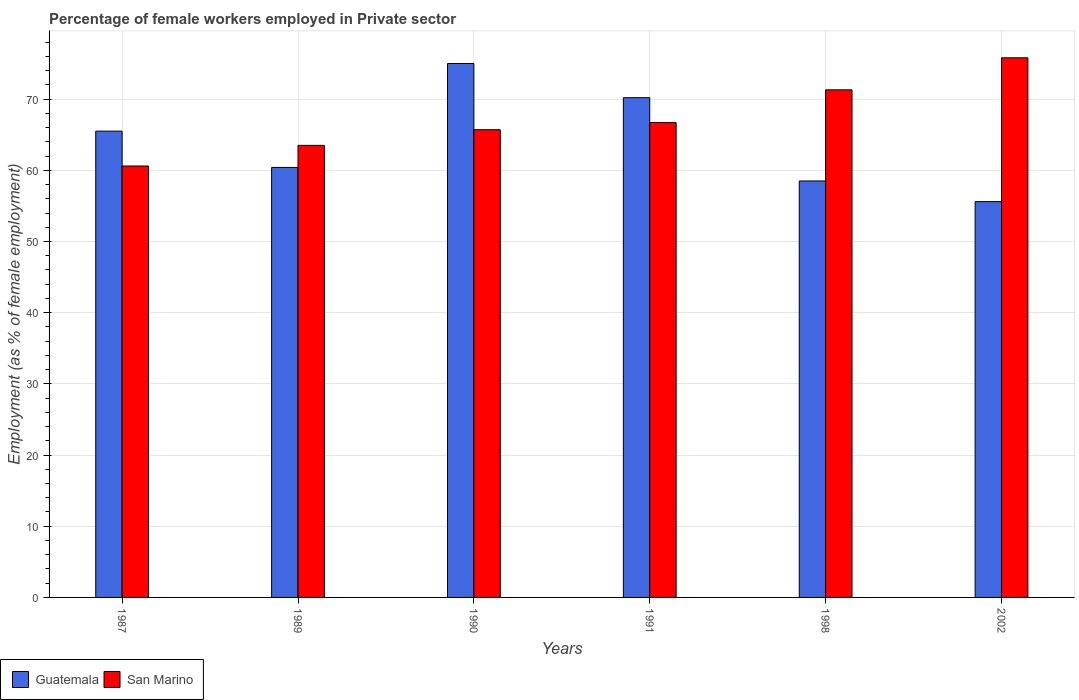How many different coloured bars are there?
Ensure brevity in your answer.  2. How many groups of bars are there?
Keep it short and to the point. 6. Are the number of bars per tick equal to the number of legend labels?
Your answer should be compact. Yes. Are the number of bars on each tick of the X-axis equal?
Your response must be concise. Yes. What is the label of the 3rd group of bars from the left?
Ensure brevity in your answer.  1990. What is the percentage of females employed in Private sector in San Marino in 2002?
Provide a succinct answer. 75.8. Across all years, what is the maximum percentage of females employed in Private sector in San Marino?
Provide a succinct answer. 75.8. Across all years, what is the minimum percentage of females employed in Private sector in San Marino?
Provide a short and direct response. 60.6. In which year was the percentage of females employed in Private sector in San Marino maximum?
Provide a succinct answer. 2002. What is the total percentage of females employed in Private sector in San Marino in the graph?
Provide a succinct answer. 403.6. What is the difference between the percentage of females employed in Private sector in Guatemala in 1998 and that in 2002?
Offer a terse response. 2.9. What is the difference between the percentage of females employed in Private sector in San Marino in 1998 and the percentage of females employed in Private sector in Guatemala in 1991?
Provide a short and direct response. 1.1. What is the average percentage of females employed in Private sector in San Marino per year?
Keep it short and to the point. 67.27. In the year 1998, what is the difference between the percentage of females employed in Private sector in San Marino and percentage of females employed in Private sector in Guatemala?
Make the answer very short. 12.8. In how many years, is the percentage of females employed in Private sector in Guatemala greater than 38 %?
Give a very brief answer. 6. What is the ratio of the percentage of females employed in Private sector in Guatemala in 1990 to that in 1998?
Give a very brief answer. 1.28. Is the percentage of females employed in Private sector in San Marino in 1989 less than that in 2002?
Provide a short and direct response. Yes. Is the difference between the percentage of females employed in Private sector in San Marino in 1987 and 1991 greater than the difference between the percentage of females employed in Private sector in Guatemala in 1987 and 1991?
Offer a very short reply. No. What is the difference between the highest and the second highest percentage of females employed in Private sector in Guatemala?
Offer a terse response. 4.8. What is the difference between the highest and the lowest percentage of females employed in Private sector in San Marino?
Provide a short and direct response. 15.2. In how many years, is the percentage of females employed in Private sector in Guatemala greater than the average percentage of females employed in Private sector in Guatemala taken over all years?
Provide a succinct answer. 3. Is the sum of the percentage of females employed in Private sector in San Marino in 1987 and 2002 greater than the maximum percentage of females employed in Private sector in Guatemala across all years?
Your response must be concise. Yes. What does the 1st bar from the left in 1991 represents?
Offer a very short reply. Guatemala. What does the 2nd bar from the right in 1989 represents?
Offer a terse response. Guatemala. Are all the bars in the graph horizontal?
Your response must be concise. No. How many years are there in the graph?
Provide a short and direct response. 6. What is the difference between two consecutive major ticks on the Y-axis?
Offer a very short reply. 10. How many legend labels are there?
Provide a succinct answer. 2. What is the title of the graph?
Give a very brief answer. Percentage of female workers employed in Private sector. What is the label or title of the X-axis?
Ensure brevity in your answer.  Years. What is the label or title of the Y-axis?
Give a very brief answer. Employment (as % of female employment). What is the Employment (as % of female employment) in Guatemala in 1987?
Your answer should be very brief. 65.5. What is the Employment (as % of female employment) in San Marino in 1987?
Offer a very short reply. 60.6. What is the Employment (as % of female employment) of Guatemala in 1989?
Ensure brevity in your answer.  60.4. What is the Employment (as % of female employment) in San Marino in 1989?
Offer a very short reply. 63.5. What is the Employment (as % of female employment) of Guatemala in 1990?
Your answer should be compact. 75. What is the Employment (as % of female employment) of San Marino in 1990?
Make the answer very short. 65.7. What is the Employment (as % of female employment) in Guatemala in 1991?
Provide a short and direct response. 70.2. What is the Employment (as % of female employment) in San Marino in 1991?
Your answer should be compact. 66.7. What is the Employment (as % of female employment) of Guatemala in 1998?
Your answer should be very brief. 58.5. What is the Employment (as % of female employment) in San Marino in 1998?
Your answer should be very brief. 71.3. What is the Employment (as % of female employment) of Guatemala in 2002?
Your response must be concise. 55.6. What is the Employment (as % of female employment) of San Marino in 2002?
Your answer should be compact. 75.8. Across all years, what is the maximum Employment (as % of female employment) of San Marino?
Your answer should be very brief. 75.8. Across all years, what is the minimum Employment (as % of female employment) in Guatemala?
Make the answer very short. 55.6. Across all years, what is the minimum Employment (as % of female employment) in San Marino?
Provide a succinct answer. 60.6. What is the total Employment (as % of female employment) of Guatemala in the graph?
Offer a terse response. 385.2. What is the total Employment (as % of female employment) of San Marino in the graph?
Offer a very short reply. 403.6. What is the difference between the Employment (as % of female employment) in San Marino in 1987 and that in 1989?
Ensure brevity in your answer.  -2.9. What is the difference between the Employment (as % of female employment) in Guatemala in 1987 and that in 1990?
Give a very brief answer. -9.5. What is the difference between the Employment (as % of female employment) in Guatemala in 1987 and that in 1998?
Make the answer very short. 7. What is the difference between the Employment (as % of female employment) of San Marino in 1987 and that in 1998?
Your answer should be compact. -10.7. What is the difference between the Employment (as % of female employment) of San Marino in 1987 and that in 2002?
Provide a short and direct response. -15.2. What is the difference between the Employment (as % of female employment) in Guatemala in 1989 and that in 1990?
Your answer should be very brief. -14.6. What is the difference between the Employment (as % of female employment) in San Marino in 1989 and that in 1990?
Provide a succinct answer. -2.2. What is the difference between the Employment (as % of female employment) of San Marino in 1989 and that in 1991?
Offer a very short reply. -3.2. What is the difference between the Employment (as % of female employment) in Guatemala in 1989 and that in 1998?
Keep it short and to the point. 1.9. What is the difference between the Employment (as % of female employment) in San Marino in 1989 and that in 1998?
Provide a succinct answer. -7.8. What is the difference between the Employment (as % of female employment) in Guatemala in 1989 and that in 2002?
Make the answer very short. 4.8. What is the difference between the Employment (as % of female employment) in Guatemala in 1990 and that in 1991?
Your response must be concise. 4.8. What is the difference between the Employment (as % of female employment) of San Marino in 1990 and that in 1991?
Provide a short and direct response. -1. What is the difference between the Employment (as % of female employment) in Guatemala in 1990 and that in 1998?
Provide a succinct answer. 16.5. What is the difference between the Employment (as % of female employment) of San Marino in 1990 and that in 1998?
Provide a short and direct response. -5.6. What is the difference between the Employment (as % of female employment) in San Marino in 1990 and that in 2002?
Your answer should be very brief. -10.1. What is the difference between the Employment (as % of female employment) in Guatemala in 1991 and that in 1998?
Your answer should be very brief. 11.7. What is the difference between the Employment (as % of female employment) in Guatemala in 1998 and that in 2002?
Offer a very short reply. 2.9. What is the difference between the Employment (as % of female employment) in San Marino in 1998 and that in 2002?
Keep it short and to the point. -4.5. What is the difference between the Employment (as % of female employment) in Guatemala in 1987 and the Employment (as % of female employment) in San Marino in 1998?
Keep it short and to the point. -5.8. What is the difference between the Employment (as % of female employment) of Guatemala in 1987 and the Employment (as % of female employment) of San Marino in 2002?
Make the answer very short. -10.3. What is the difference between the Employment (as % of female employment) in Guatemala in 1989 and the Employment (as % of female employment) in San Marino in 1998?
Make the answer very short. -10.9. What is the difference between the Employment (as % of female employment) in Guatemala in 1989 and the Employment (as % of female employment) in San Marino in 2002?
Offer a terse response. -15.4. What is the difference between the Employment (as % of female employment) of Guatemala in 1990 and the Employment (as % of female employment) of San Marino in 2002?
Provide a succinct answer. -0.8. What is the difference between the Employment (as % of female employment) in Guatemala in 1998 and the Employment (as % of female employment) in San Marino in 2002?
Provide a succinct answer. -17.3. What is the average Employment (as % of female employment) of Guatemala per year?
Provide a short and direct response. 64.2. What is the average Employment (as % of female employment) of San Marino per year?
Your answer should be compact. 67.27. In the year 1987, what is the difference between the Employment (as % of female employment) in Guatemala and Employment (as % of female employment) in San Marino?
Offer a very short reply. 4.9. In the year 2002, what is the difference between the Employment (as % of female employment) in Guatemala and Employment (as % of female employment) in San Marino?
Your response must be concise. -20.2. What is the ratio of the Employment (as % of female employment) in Guatemala in 1987 to that in 1989?
Provide a short and direct response. 1.08. What is the ratio of the Employment (as % of female employment) in San Marino in 1987 to that in 1989?
Your response must be concise. 0.95. What is the ratio of the Employment (as % of female employment) of Guatemala in 1987 to that in 1990?
Your answer should be very brief. 0.87. What is the ratio of the Employment (as % of female employment) of San Marino in 1987 to that in 1990?
Ensure brevity in your answer.  0.92. What is the ratio of the Employment (as % of female employment) of Guatemala in 1987 to that in 1991?
Your response must be concise. 0.93. What is the ratio of the Employment (as % of female employment) of San Marino in 1987 to that in 1991?
Your answer should be very brief. 0.91. What is the ratio of the Employment (as % of female employment) in Guatemala in 1987 to that in 1998?
Ensure brevity in your answer.  1.12. What is the ratio of the Employment (as % of female employment) of San Marino in 1987 to that in 1998?
Your response must be concise. 0.85. What is the ratio of the Employment (as % of female employment) in Guatemala in 1987 to that in 2002?
Offer a terse response. 1.18. What is the ratio of the Employment (as % of female employment) in San Marino in 1987 to that in 2002?
Offer a very short reply. 0.8. What is the ratio of the Employment (as % of female employment) in Guatemala in 1989 to that in 1990?
Provide a succinct answer. 0.81. What is the ratio of the Employment (as % of female employment) in San Marino in 1989 to that in 1990?
Give a very brief answer. 0.97. What is the ratio of the Employment (as % of female employment) in Guatemala in 1989 to that in 1991?
Keep it short and to the point. 0.86. What is the ratio of the Employment (as % of female employment) in San Marino in 1989 to that in 1991?
Make the answer very short. 0.95. What is the ratio of the Employment (as % of female employment) in Guatemala in 1989 to that in 1998?
Your response must be concise. 1.03. What is the ratio of the Employment (as % of female employment) in San Marino in 1989 to that in 1998?
Ensure brevity in your answer.  0.89. What is the ratio of the Employment (as % of female employment) in Guatemala in 1989 to that in 2002?
Provide a short and direct response. 1.09. What is the ratio of the Employment (as % of female employment) in San Marino in 1989 to that in 2002?
Give a very brief answer. 0.84. What is the ratio of the Employment (as % of female employment) of Guatemala in 1990 to that in 1991?
Give a very brief answer. 1.07. What is the ratio of the Employment (as % of female employment) of San Marino in 1990 to that in 1991?
Ensure brevity in your answer.  0.98. What is the ratio of the Employment (as % of female employment) in Guatemala in 1990 to that in 1998?
Provide a succinct answer. 1.28. What is the ratio of the Employment (as % of female employment) in San Marino in 1990 to that in 1998?
Make the answer very short. 0.92. What is the ratio of the Employment (as % of female employment) of Guatemala in 1990 to that in 2002?
Ensure brevity in your answer.  1.35. What is the ratio of the Employment (as % of female employment) in San Marino in 1990 to that in 2002?
Provide a succinct answer. 0.87. What is the ratio of the Employment (as % of female employment) of Guatemala in 1991 to that in 1998?
Your answer should be compact. 1.2. What is the ratio of the Employment (as % of female employment) of San Marino in 1991 to that in 1998?
Your answer should be compact. 0.94. What is the ratio of the Employment (as % of female employment) of Guatemala in 1991 to that in 2002?
Your response must be concise. 1.26. What is the ratio of the Employment (as % of female employment) in San Marino in 1991 to that in 2002?
Your answer should be compact. 0.88. What is the ratio of the Employment (as % of female employment) in Guatemala in 1998 to that in 2002?
Give a very brief answer. 1.05. What is the ratio of the Employment (as % of female employment) of San Marino in 1998 to that in 2002?
Your answer should be compact. 0.94. What is the difference between the highest and the second highest Employment (as % of female employment) in San Marino?
Provide a succinct answer. 4.5. What is the difference between the highest and the lowest Employment (as % of female employment) in Guatemala?
Offer a very short reply. 19.4. What is the difference between the highest and the lowest Employment (as % of female employment) of San Marino?
Ensure brevity in your answer.  15.2. 